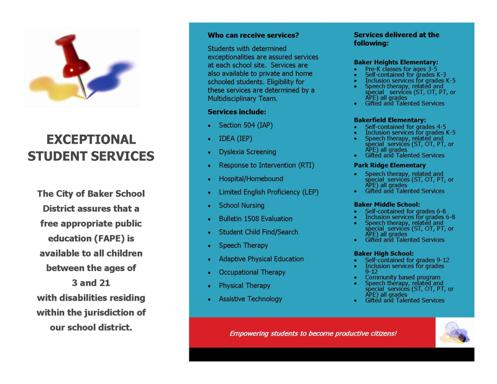How does Assistive Technology help students with disabilities? Assistive Technology offers students with disabilities tailored tools and resources to enhance their learning experiences and performances. These technologies can range from simple devices like audio books or text-to-speech applications to more complex systems like specialized computer software, facilitating greater independence and participation in their educational environment. 